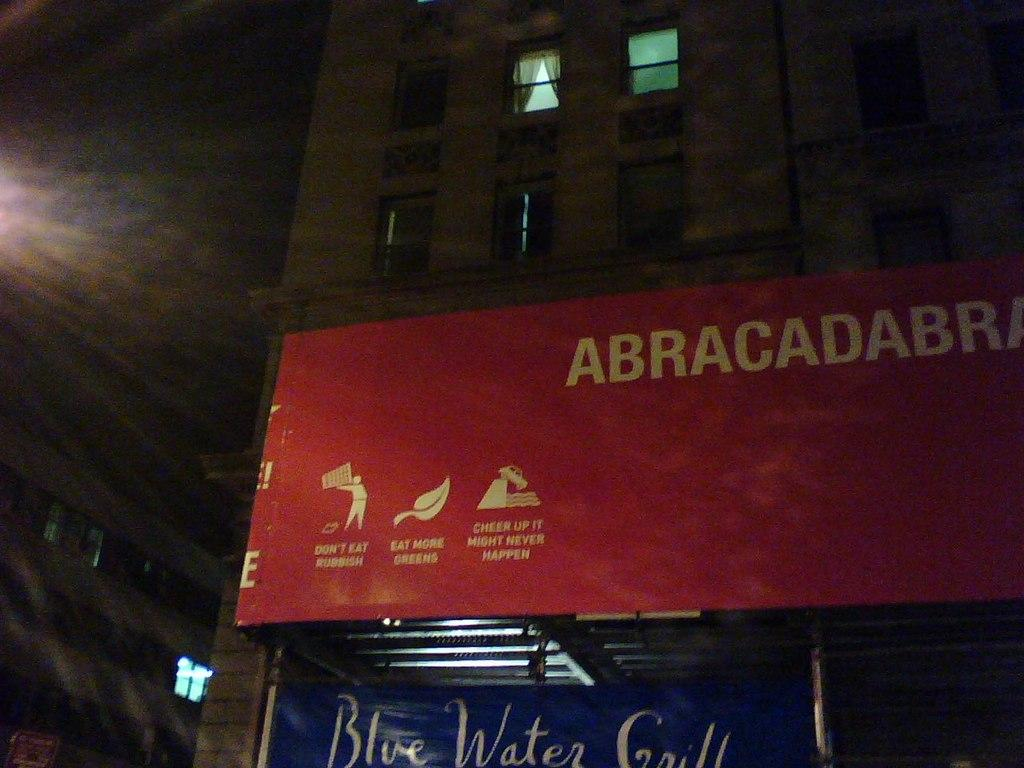<image>
Write a terse but informative summary of the picture. A red awning with the name Abracadabra on it 